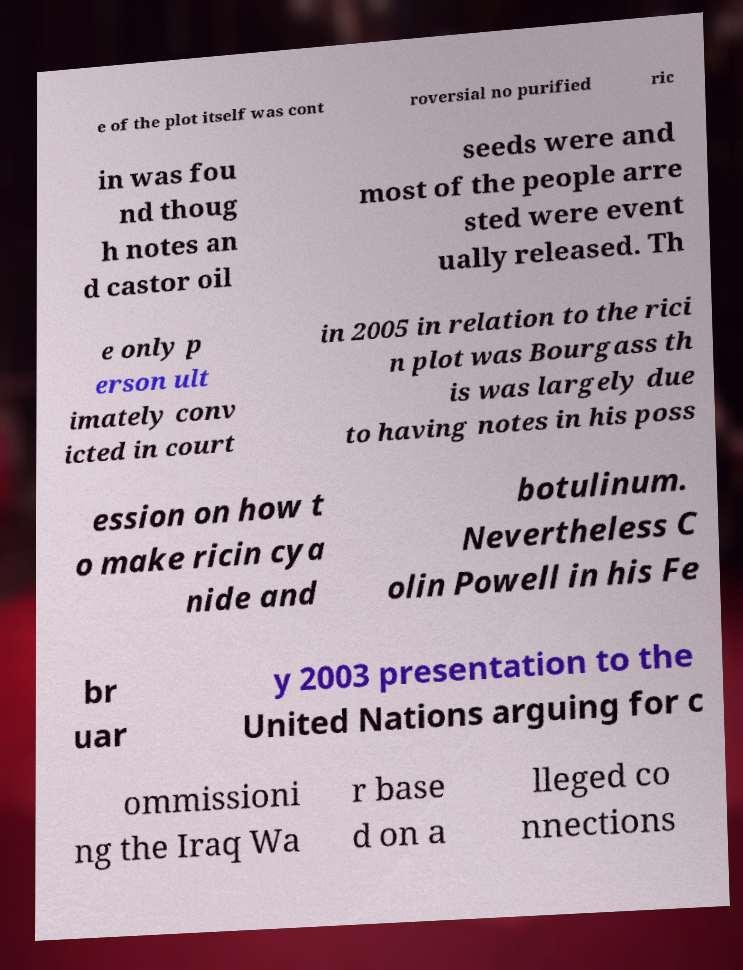What messages or text are displayed in this image? I need them in a readable, typed format. e of the plot itself was cont roversial no purified ric in was fou nd thoug h notes an d castor oil seeds were and most of the people arre sted were event ually released. Th e only p erson ult imately conv icted in court in 2005 in relation to the rici n plot was Bourgass th is was largely due to having notes in his poss ession on how t o make ricin cya nide and botulinum. Nevertheless C olin Powell in his Fe br uar y 2003 presentation to the United Nations arguing for c ommissioni ng the Iraq Wa r base d on a lleged co nnections 